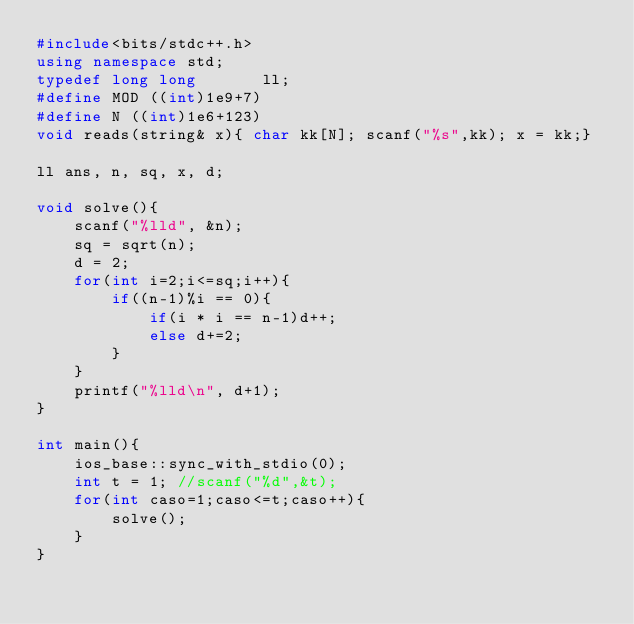<code> <loc_0><loc_0><loc_500><loc_500><_C++_>#include<bits/stdc++.h>
using namespace std;
typedef long long       ll;
#define MOD ((int)1e9+7)
#define N ((int)1e6+123)
void reads(string& x){ char kk[N]; scanf("%s",kk); x = kk;}

ll ans, n, sq, x, d;

void solve(){
    scanf("%lld", &n);
    sq = sqrt(n);
    d = 2;
    for(int i=2;i<=sq;i++){
        if((n-1)%i == 0){
            if(i * i == n-1)d++;
            else d+=2;
        }
    }
    printf("%lld\n", d+1);
}

int main(){
    ios_base::sync_with_stdio(0);
    int t = 1; //scanf("%d",&t);
    for(int caso=1;caso<=t;caso++){
        solve();
    }
}</code> 